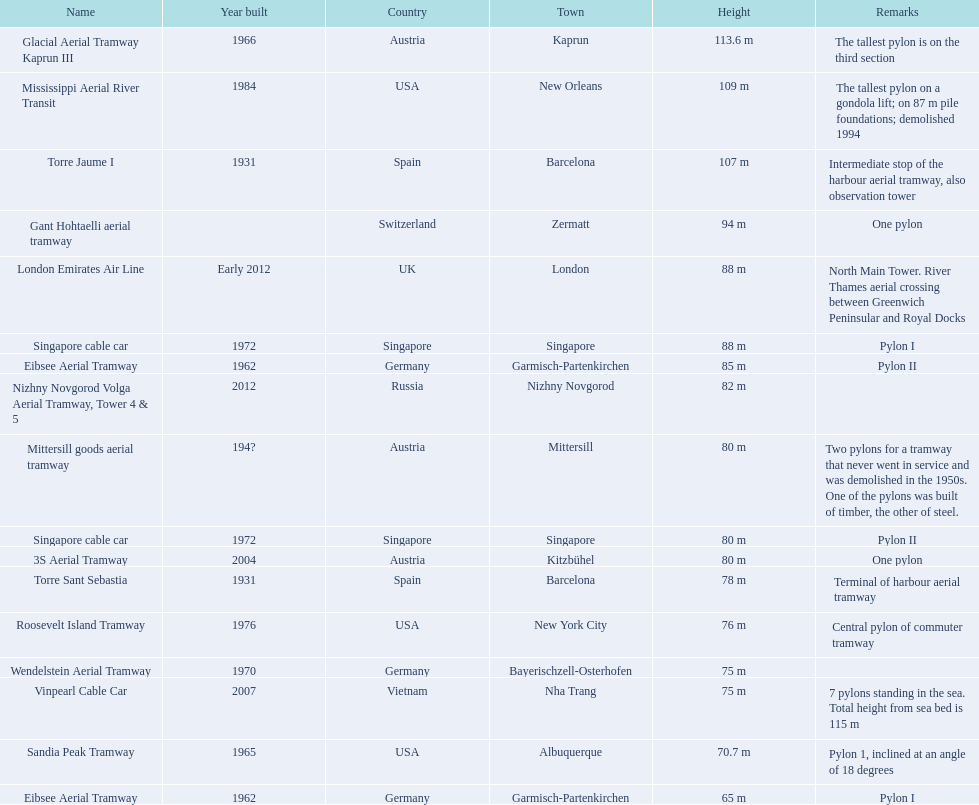Which aerial lifts are over 100 meters tall? Glacial Aerial Tramway Kaprun III, Mississippi Aerial River Transit, Torre Jaume I. Which of those was built last? Mississippi Aerial River Transit. And what is its total height? 109 m. 